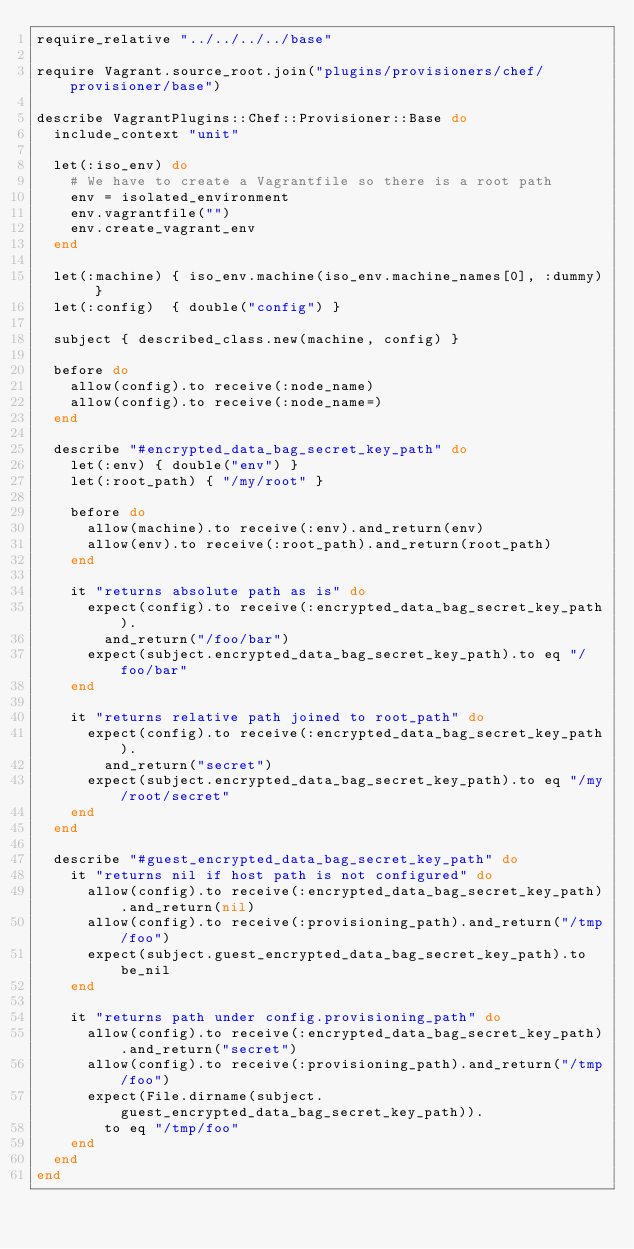<code> <loc_0><loc_0><loc_500><loc_500><_Ruby_>require_relative "../../../../base"

require Vagrant.source_root.join("plugins/provisioners/chef/provisioner/base")

describe VagrantPlugins::Chef::Provisioner::Base do
  include_context "unit"

  let(:iso_env) do
    # We have to create a Vagrantfile so there is a root path
    env = isolated_environment
    env.vagrantfile("")
    env.create_vagrant_env
  end

  let(:machine) { iso_env.machine(iso_env.machine_names[0], :dummy) }
  let(:config)  { double("config") }

  subject { described_class.new(machine, config) }

  before do
    allow(config).to receive(:node_name)
    allow(config).to receive(:node_name=)
  end

  describe "#encrypted_data_bag_secret_key_path" do
    let(:env) { double("env") }
    let(:root_path) { "/my/root" }

    before do
      allow(machine).to receive(:env).and_return(env)
      allow(env).to receive(:root_path).and_return(root_path)
    end

    it "returns absolute path as is" do
      expect(config).to receive(:encrypted_data_bag_secret_key_path).
        and_return("/foo/bar")
      expect(subject.encrypted_data_bag_secret_key_path).to eq "/foo/bar"
    end

    it "returns relative path joined to root_path" do
      expect(config).to receive(:encrypted_data_bag_secret_key_path).
        and_return("secret")
      expect(subject.encrypted_data_bag_secret_key_path).to eq "/my/root/secret"
    end
  end

  describe "#guest_encrypted_data_bag_secret_key_path" do
    it "returns nil if host path is not configured" do
      allow(config).to receive(:encrypted_data_bag_secret_key_path).and_return(nil)
      allow(config).to receive(:provisioning_path).and_return("/tmp/foo")
      expect(subject.guest_encrypted_data_bag_secret_key_path).to be_nil
    end

    it "returns path under config.provisioning_path" do
      allow(config).to receive(:encrypted_data_bag_secret_key_path).and_return("secret")
      allow(config).to receive(:provisioning_path).and_return("/tmp/foo")
      expect(File.dirname(subject.guest_encrypted_data_bag_secret_key_path)).
        to eq "/tmp/foo"
    end
  end
end
</code> 